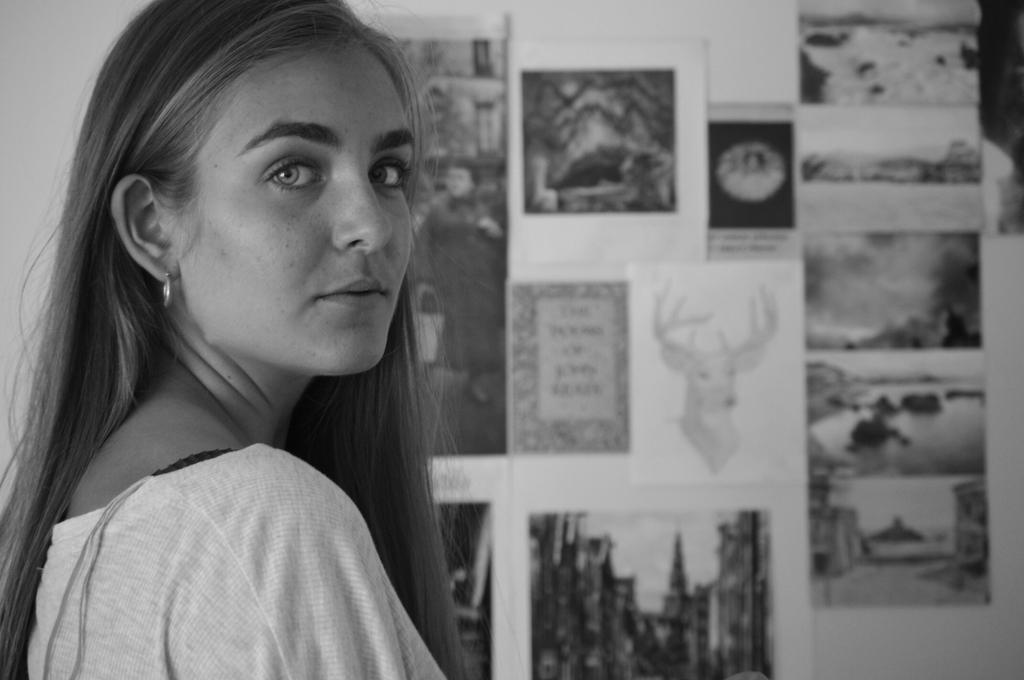In one or two sentences, can you explain what this image depicts? In this picture we can see a woman, in front we can see some photos on the board. 